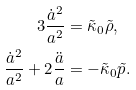Convert formula to latex. <formula><loc_0><loc_0><loc_500><loc_500>3 \frac { \dot { a } ^ { 2 } } { a ^ { 2 } } & = \tilde { \kappa } _ { 0 } \tilde { \rho } , \\ \frac { \dot { a } ^ { 2 } } { a ^ { 2 } } + 2 \frac { \ddot { a } } { a } & = - \tilde { \kappa } _ { 0 } \tilde { p } .</formula> 